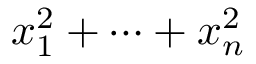Convert formula to latex. <formula><loc_0><loc_0><loc_500><loc_500>x _ { 1 } ^ { 2 } + \cdots + x _ { n } ^ { 2 }</formula> 